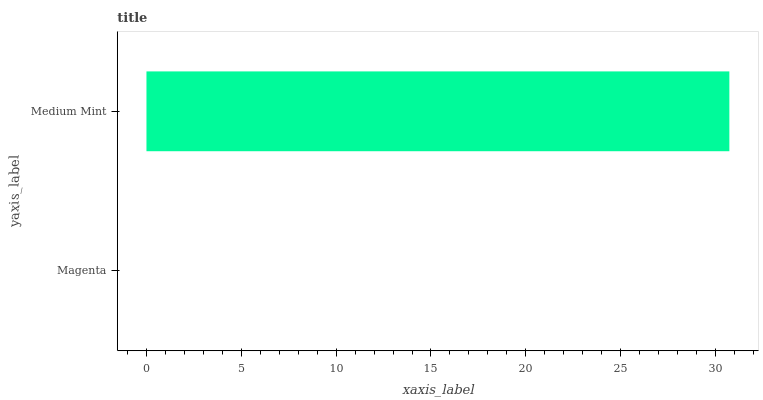Is Magenta the minimum?
Answer yes or no. Yes. Is Medium Mint the maximum?
Answer yes or no. Yes. Is Medium Mint the minimum?
Answer yes or no. No. Is Medium Mint greater than Magenta?
Answer yes or no. Yes. Is Magenta less than Medium Mint?
Answer yes or no. Yes. Is Magenta greater than Medium Mint?
Answer yes or no. No. Is Medium Mint less than Magenta?
Answer yes or no. No. Is Medium Mint the high median?
Answer yes or no. Yes. Is Magenta the low median?
Answer yes or no. Yes. Is Magenta the high median?
Answer yes or no. No. Is Medium Mint the low median?
Answer yes or no. No. 